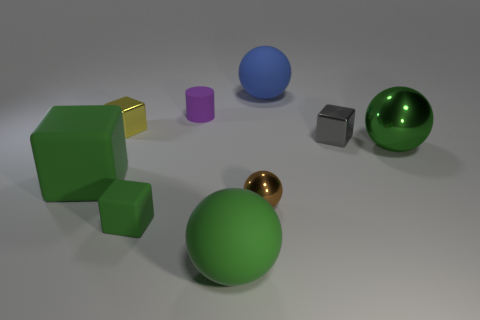Why might the green cube be split into two different shades? The green cube's dual shades could be an artistic choice to showcase the play of light on surfaces, or to demonstrate texturing and shading in a 3D environment for educational purposes, perhaps to illustrate concepts of shadow and depth. What does the color variety tell us about the composition? The variety of colors used in the composition serves to create visual interest. It allows viewers to compare the reflective and textural differences between the objects more effectively and can make the scene more appealing and engaging to observe. 